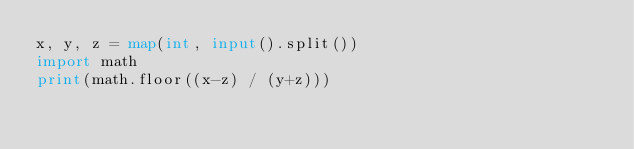Convert code to text. <code><loc_0><loc_0><loc_500><loc_500><_Python_>x, y, z = map(int, input().split())
import math
print(math.floor((x-z) / (y+z)))</code> 